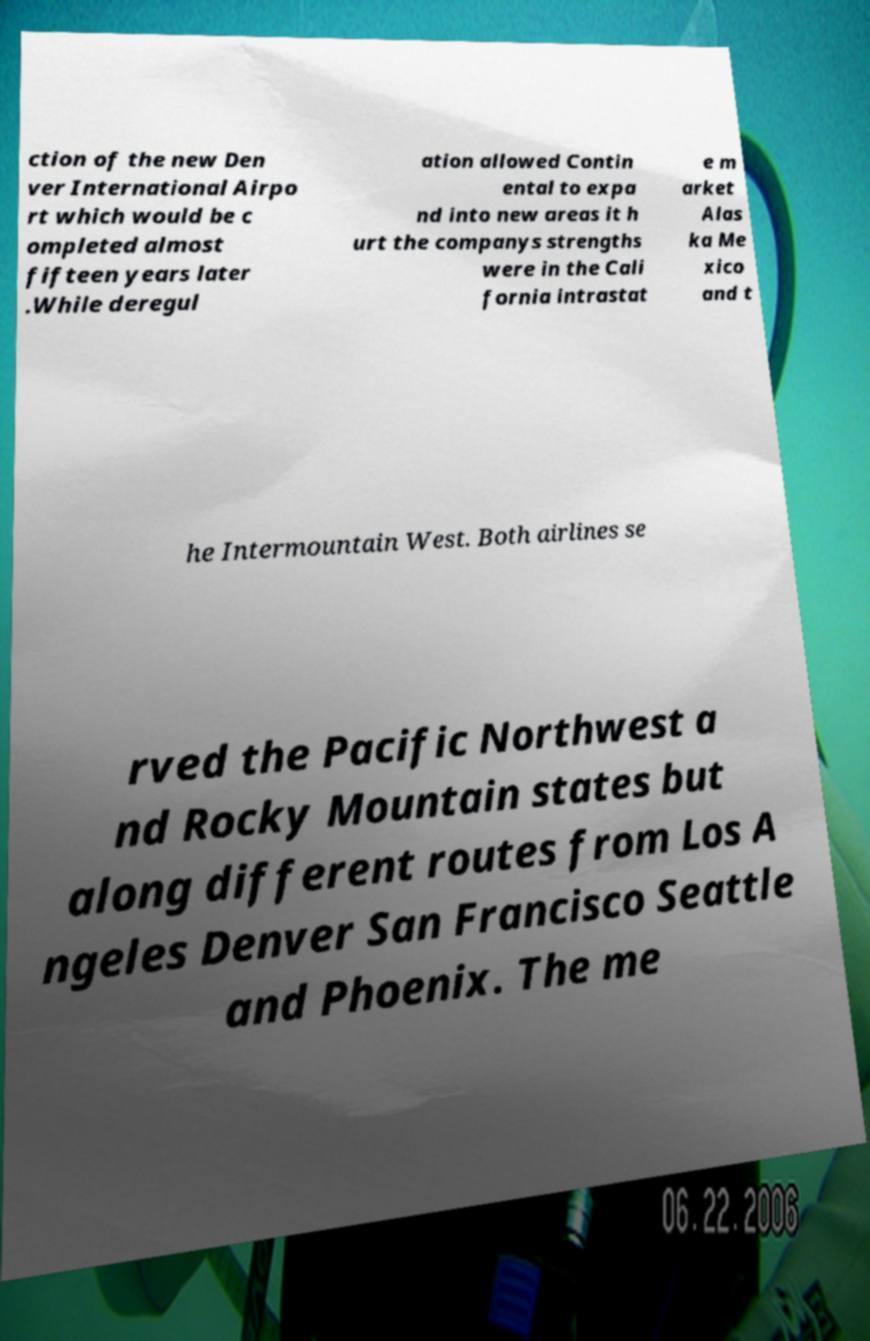What messages or text are displayed in this image? I need them in a readable, typed format. ction of the new Den ver International Airpo rt which would be c ompleted almost fifteen years later .While deregul ation allowed Contin ental to expa nd into new areas it h urt the companys strengths were in the Cali fornia intrastat e m arket Alas ka Me xico and t he Intermountain West. Both airlines se rved the Pacific Northwest a nd Rocky Mountain states but along different routes from Los A ngeles Denver San Francisco Seattle and Phoenix. The me 